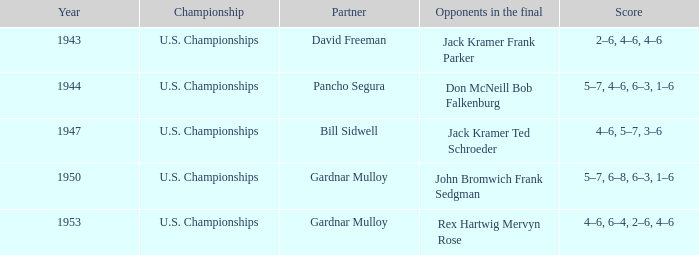Which Partner has Opponents in the final of john bromwich frank sedgman? Gardnar Mulloy. Could you help me parse every detail presented in this table? {'header': ['Year', 'Championship', 'Partner', 'Opponents in the final', 'Score'], 'rows': [['1943', 'U.S. Championships', 'David Freeman', 'Jack Kramer Frank Parker', '2–6, 4–6, 4–6'], ['1944', 'U.S. Championships', 'Pancho Segura', 'Don McNeill Bob Falkenburg', '5–7, 4–6, 6–3, 1–6'], ['1947', 'U.S. Championships', 'Bill Sidwell', 'Jack Kramer Ted Schroeder', '4–6, 5–7, 3–6'], ['1950', 'U.S. Championships', 'Gardnar Mulloy', 'John Bromwich Frank Sedgman', '5–7, 6–8, 6–3, 1–6'], ['1953', 'U.S. Championships', 'Gardnar Mulloy', 'Rex Hartwig Mervyn Rose', '4–6, 6–4, 2–6, 4–6']]} 